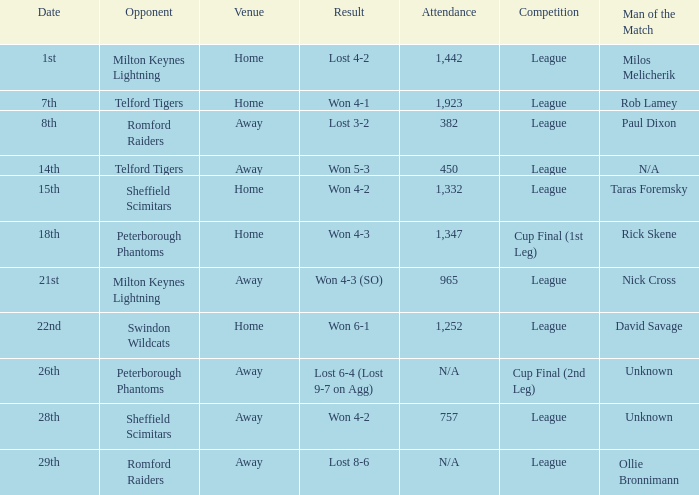Who was the Man of the Match when the opponent was Milton Keynes Lightning and the venue was Away? Nick Cross. 